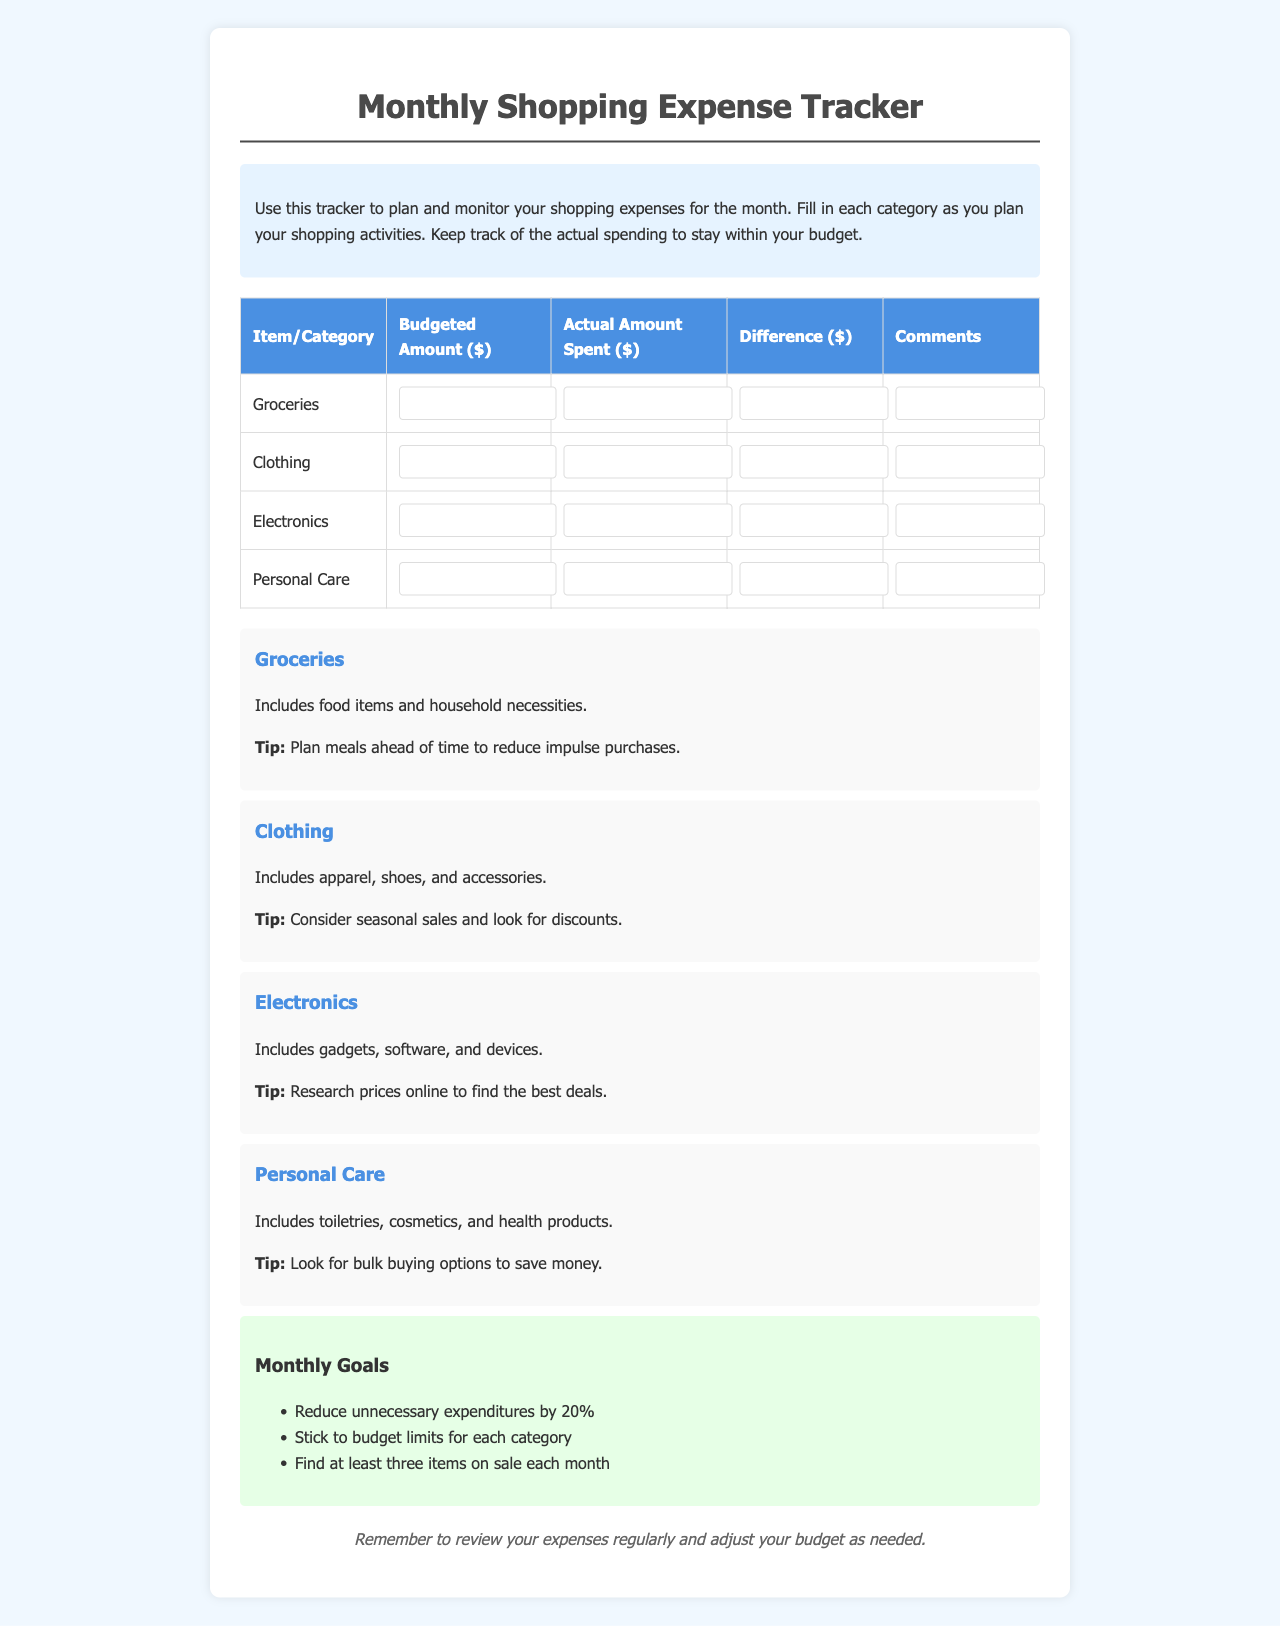What is the purpose of the tracker? The tracker is used to plan and monitor shopping expenses for the month.
Answer: To plan and monitor shopping expenses How many categories are listed in the table? The document lists four categories: Groceries, Clothing, Electronics, and Personal Care.
Answer: Four What is the color of the header in the table? The header in the table has a background color of #4a90e2.
Answer: #4a90e2 What is the budget tip for groceries? The tip for groceries is to plan meals ahead of time to reduce impulse purchases.
Answer: Plan meals ahead of time What is the monthly goal related to unnecessary expenditures? The goal is to reduce unnecessary expenditures by 20%.
Answer: Reduce unnecessary expenditures by 20% What should you look for to save money on personal care items? You should look for bulk buying options to save money.
Answer: Bulk buying options What category includes gadgets and devices? The category that includes gadgets and devices is Electronics.
Answer: Electronics What can you do to find the best deals on electronics? You can research prices online to find the best deals.
Answer: Research prices online What is the format of the planned budget input in the form? The input for the planned budget is in numeric format (number).
Answer: Numeric format 